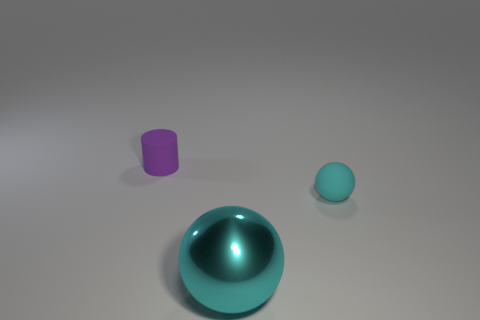Do the big ball and the tiny sphere have the same material?
Provide a succinct answer. No. What number of spheres are either metallic objects or small blue things?
Your response must be concise. 1. The object behind the matte object that is in front of the purple matte object is what color?
Give a very brief answer. Purple. What size is the other ball that is the same color as the big metal ball?
Provide a succinct answer. Small. There is a tiny object that is behind the small matte thing in front of the cylinder; how many large metal spheres are right of it?
Your answer should be compact. 1. Is the shape of the matte object that is in front of the purple cylinder the same as the big shiny thing that is to the right of the tiny purple matte cylinder?
Provide a short and direct response. Yes. How many objects are either shiny objects or blue cubes?
Your response must be concise. 1. What material is the small thing that is in front of the matte object that is behind the tiny cyan sphere made of?
Your response must be concise. Rubber. Are there any large metallic objects that have the same color as the large metallic sphere?
Make the answer very short. No. There is another rubber thing that is the same size as the purple rubber object; what is its color?
Ensure brevity in your answer.  Cyan. 